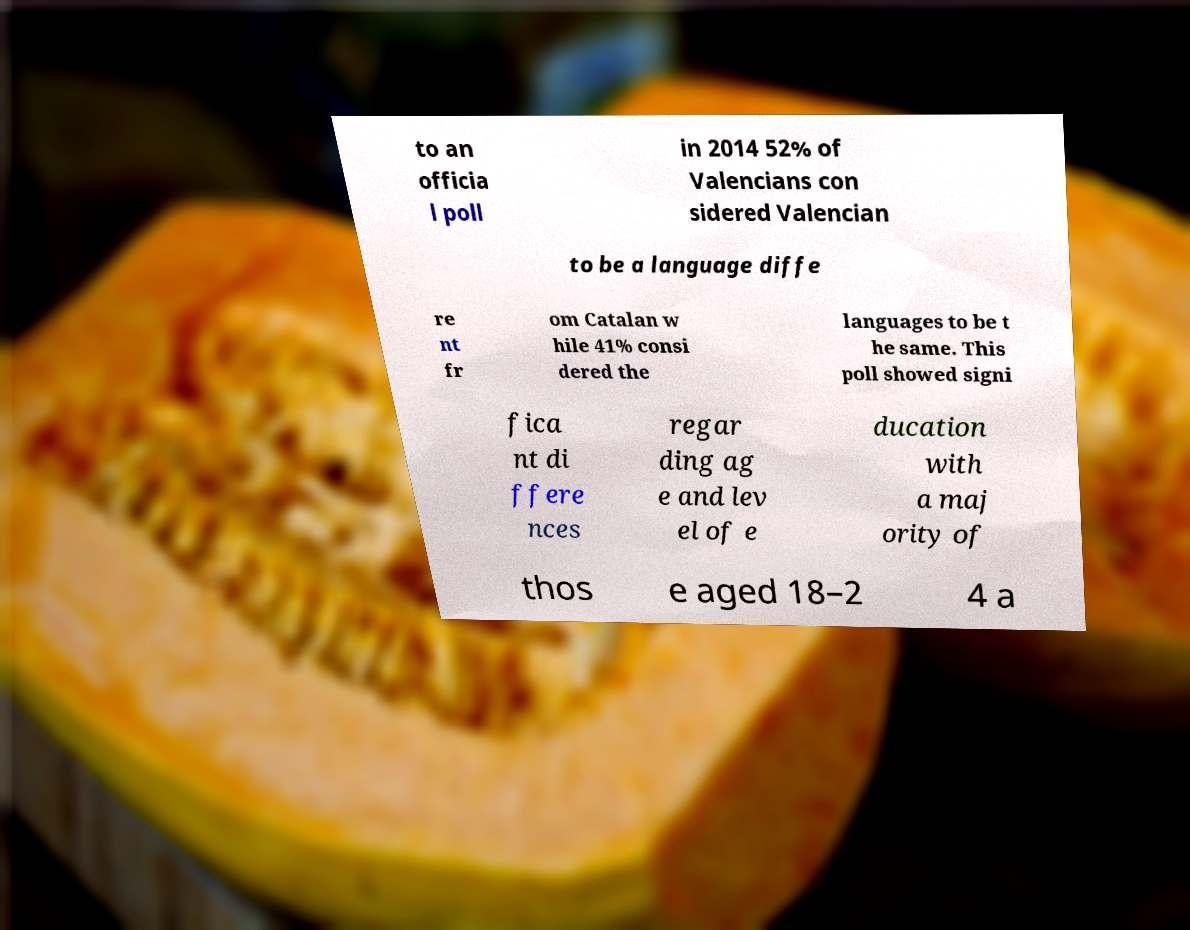There's text embedded in this image that I need extracted. Can you transcribe it verbatim? to an officia l poll in 2014 52% of Valencians con sidered Valencian to be a language diffe re nt fr om Catalan w hile 41% consi dered the languages to be t he same. This poll showed signi fica nt di ffere nces regar ding ag e and lev el of e ducation with a maj ority of thos e aged 18–2 4 a 